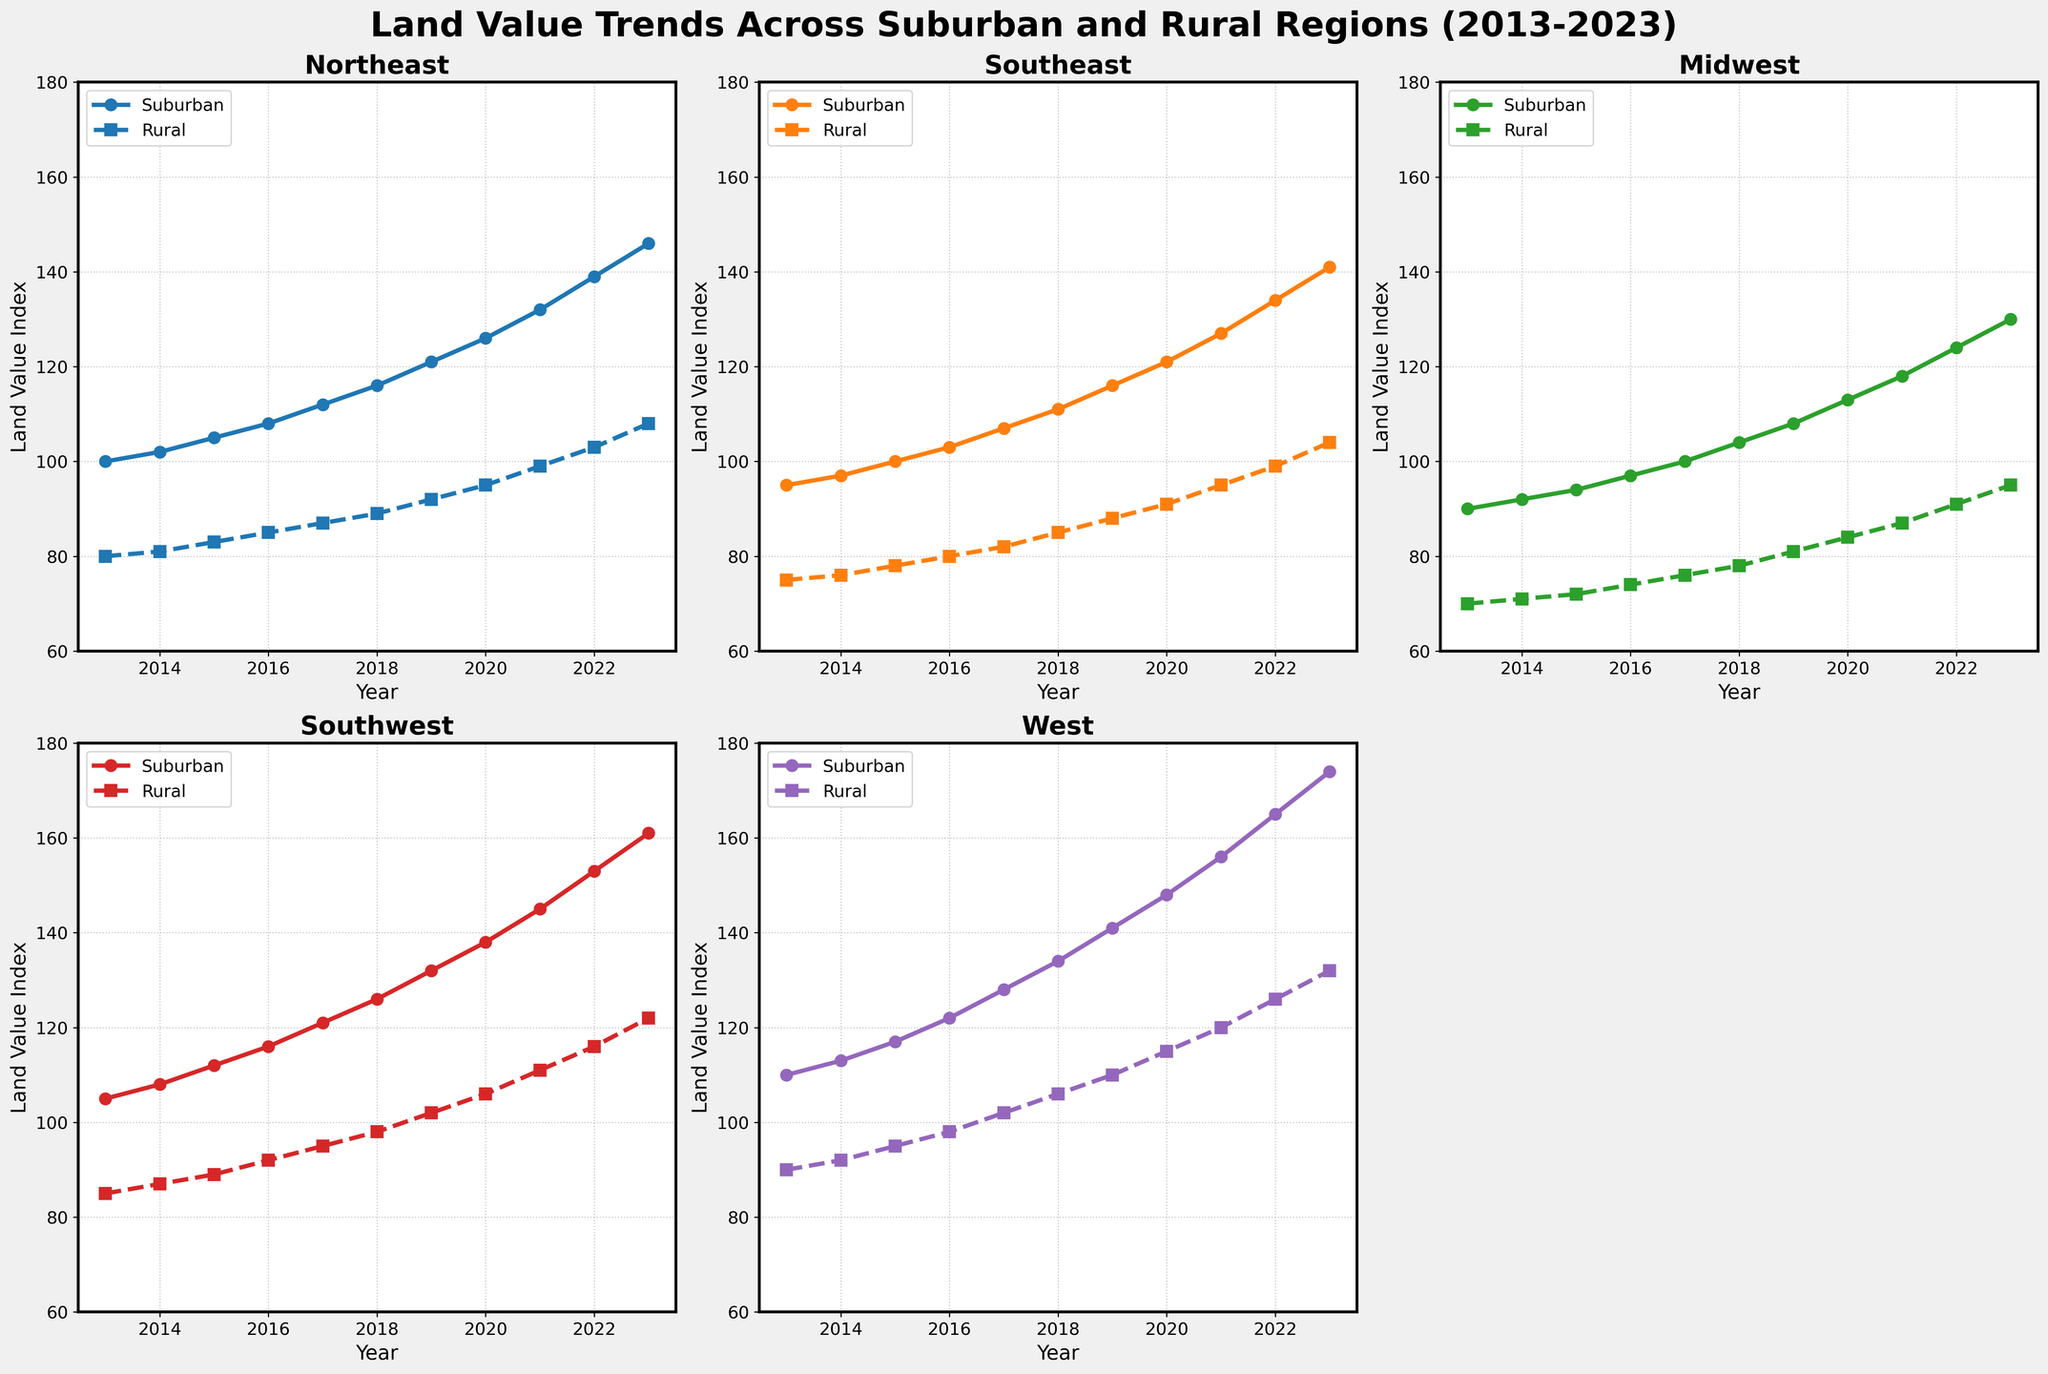What is the difference in land value between suburban and rural areas in the Northeast region in 2023? The plot for the Northeast region shows the land value for both suburban and rural areas in 2023. The suburban area value is 146, and the rural area value is 108. The difference is 146 - 108.
Answer: 38 Which region had the highest land value for suburban areas in 2020? By examining each subplot for the year 2020, the land values for suburban areas are as follows: Northeast (126), Southeast (121), Midwest (113), Southwest (138), West (148). The highest value among these is 148 in the West.
Answer: West Over which year did the Midwest rural land value first reach 80? By reviewing the plot for the Midwest region, the rural land value reaches 80 in the year 2017.
Answer: 2017 What is the average land value for Southwest rural areas over the entire period shown? To find the average, sum all the land values for Southwest rural areas from 2013 to 2023: 85, 87, 89, 92, 95, 98, 102, 106, 111, 116, 122. Sum: 1003. The number of years is 11. The average is 1003 / 11.
Answer: 91.18 Which region has the smallest gap between suburban and rural land values in 2022? Comparing the differences in 2022 for each region: Northeast (139 - 103 = 36), Southeast (134 - 99 = 35), Midwest (124 - 91 = 33), Southwest (153 - 116 = 37), West (165 - 126 = 39). The smallest gap is in the Midwest.
Answer: Midwest In which year did the Northeast suburban land value surpass 110? Reading the plot for the Northeast region, the suburban land value surpasses 110 in the year 2017.
Answer: 2017 How did the Southeast rural land value change from 2015 to 2020? The plot for the Southeast region shows the rural land value as 78 in 2015 and 91 in 2020. The change is 91 - 78.
Answer: Increased by 13 What is the cumulative increase in land value for West Suburban areas from 2013 to 2023? Starting value in 2013 is 110, final value in 2023 is 174. The cumulative increase is 174 - 110.
Answer: 64 Which region shows the most consistent increase in suburban land values over the years? By examining the general trend in the plots, every region shows an increase, but the consistency can be seen by evaluating the rate of increase and the smoothness of the trend line. The Southwest region shows a consistent pattern with steady increases each year.
Answer: Southwest Did the land values for rural areas in the Midwest region ever catch up to or surpass any suburban land values in any other region? Comparing the Midwest rural land values to suburban values in other regions, the highest value for Midwest rural is 95 in 2023. The suburban values in the same year for the other regions are all higher than 95. Therefore, the Midwest rural did not catch up or surpass any suburban values.
Answer: No 